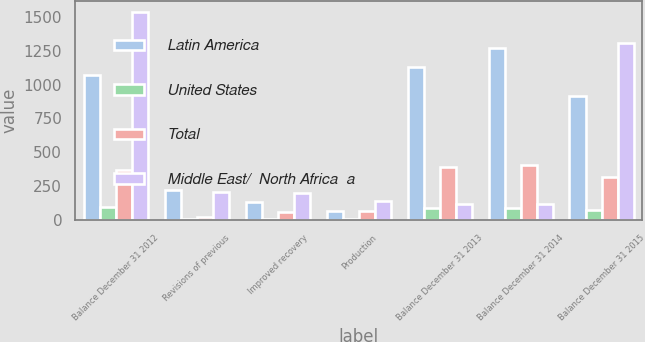<chart> <loc_0><loc_0><loc_500><loc_500><stacked_bar_chart><ecel><fcel>Balance December 31 2012<fcel>Revisions of previous<fcel>Improved recovery<fcel>Production<fcel>Balance December 31 2013<fcel>Balance December 31 2014<fcel>Balance December 31 2015<nl><fcel>Latin America<fcel>1069<fcel>220<fcel>137<fcel>64<fcel>1131<fcel>1273<fcel>915<nl><fcel>United States<fcel>96<fcel>10<fcel>7<fcel>10<fcel>88<fcel>92<fcel>77<nl><fcel>Total<fcel>373<fcel>22<fcel>60<fcel>65<fcel>394<fcel>405<fcel>317<nl><fcel>Middle East/  North Africa  a<fcel>1538<fcel>208<fcel>204<fcel>139<fcel>116.5<fcel>116.5<fcel>1309<nl></chart> 